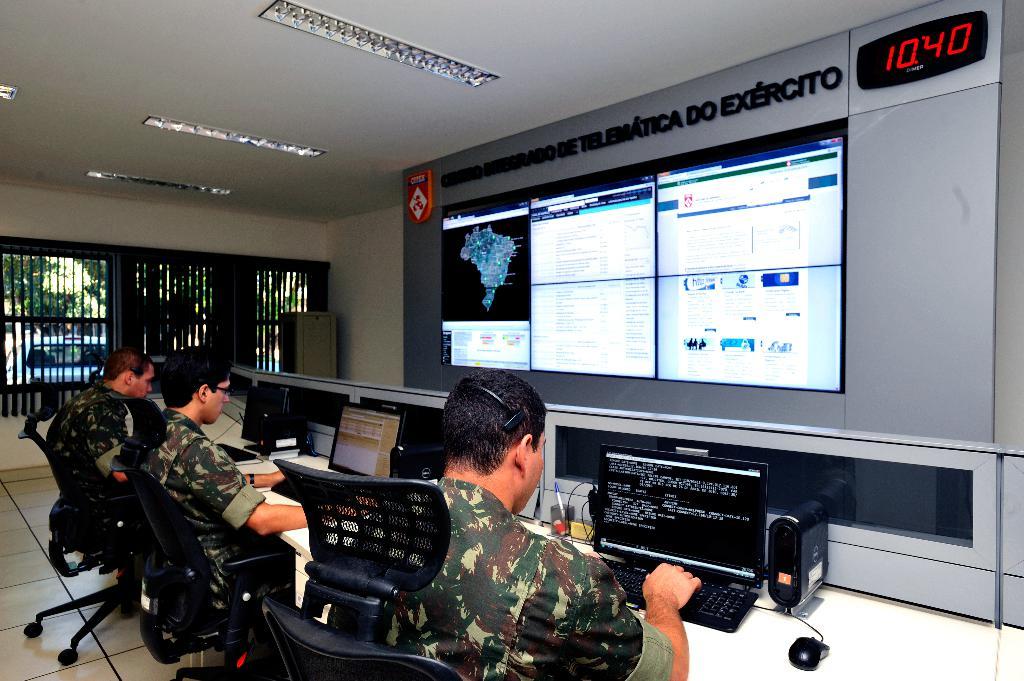What brand of computers are those?
Your answer should be compact. Dell. What is the time in this photo?
Make the answer very short. 10:40. 